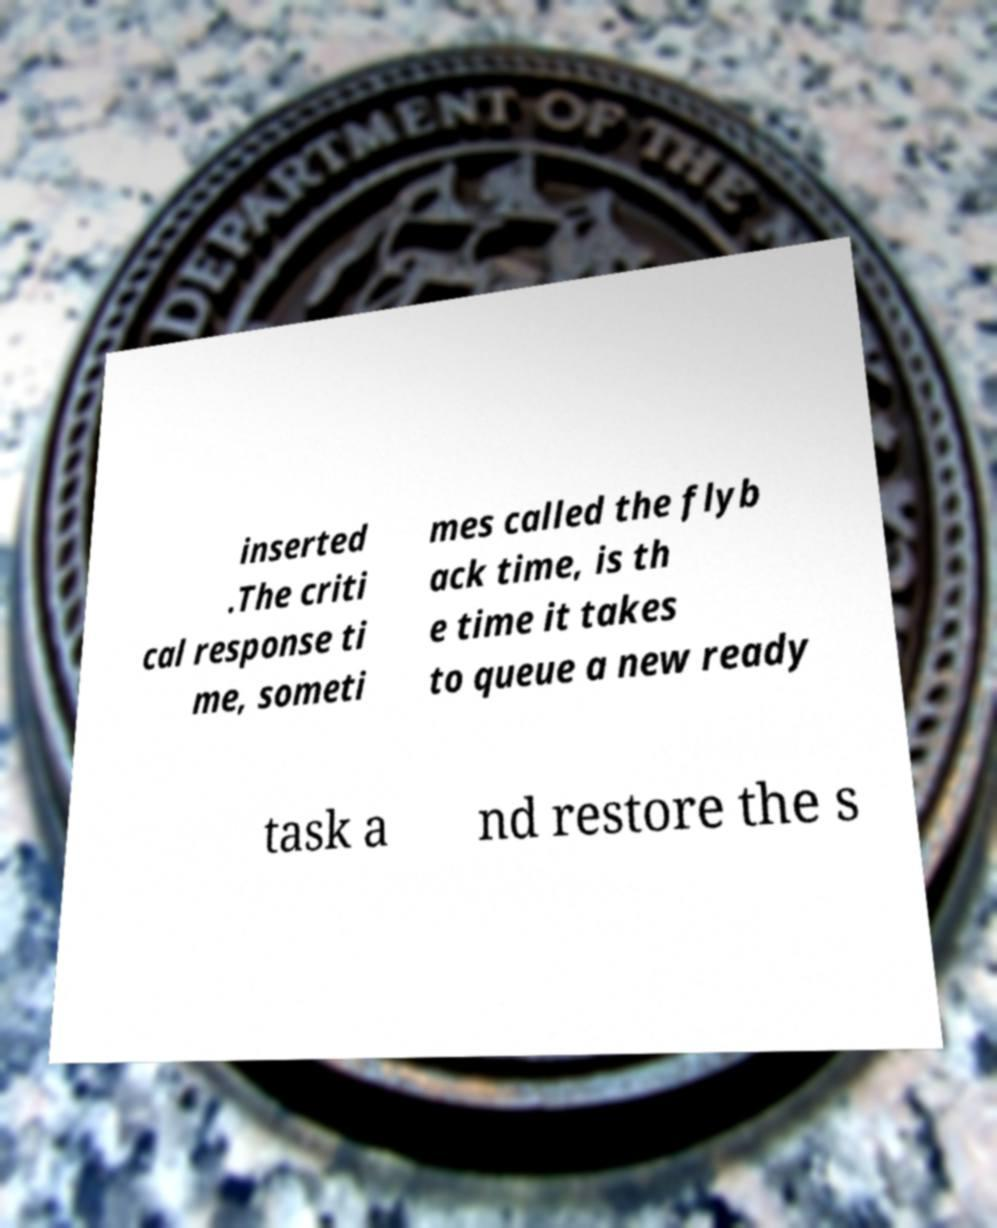Could you assist in decoding the text presented in this image and type it out clearly? inserted .The criti cal response ti me, someti mes called the flyb ack time, is th e time it takes to queue a new ready task a nd restore the s 